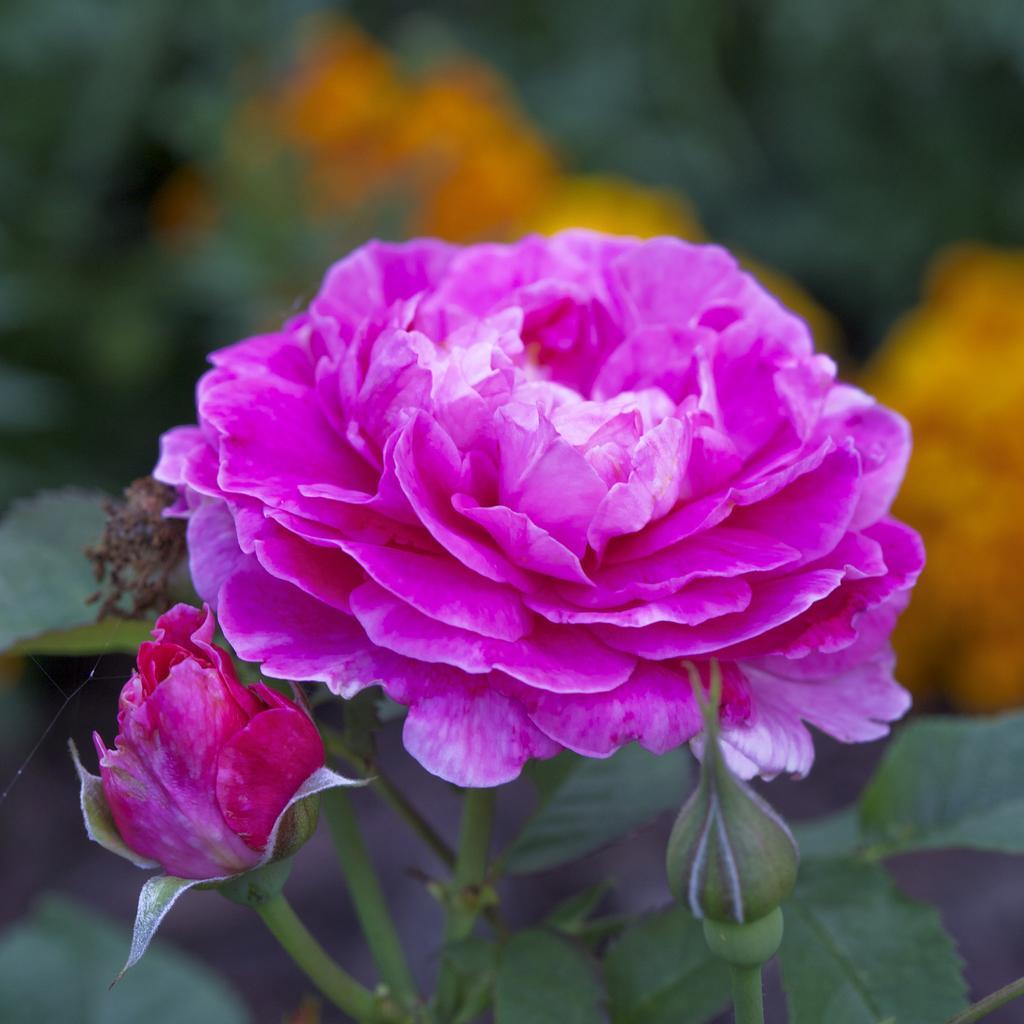Could you give a brief overview of what you see in this image? In this image we can see a rose and a bud to the stem of a plant. 